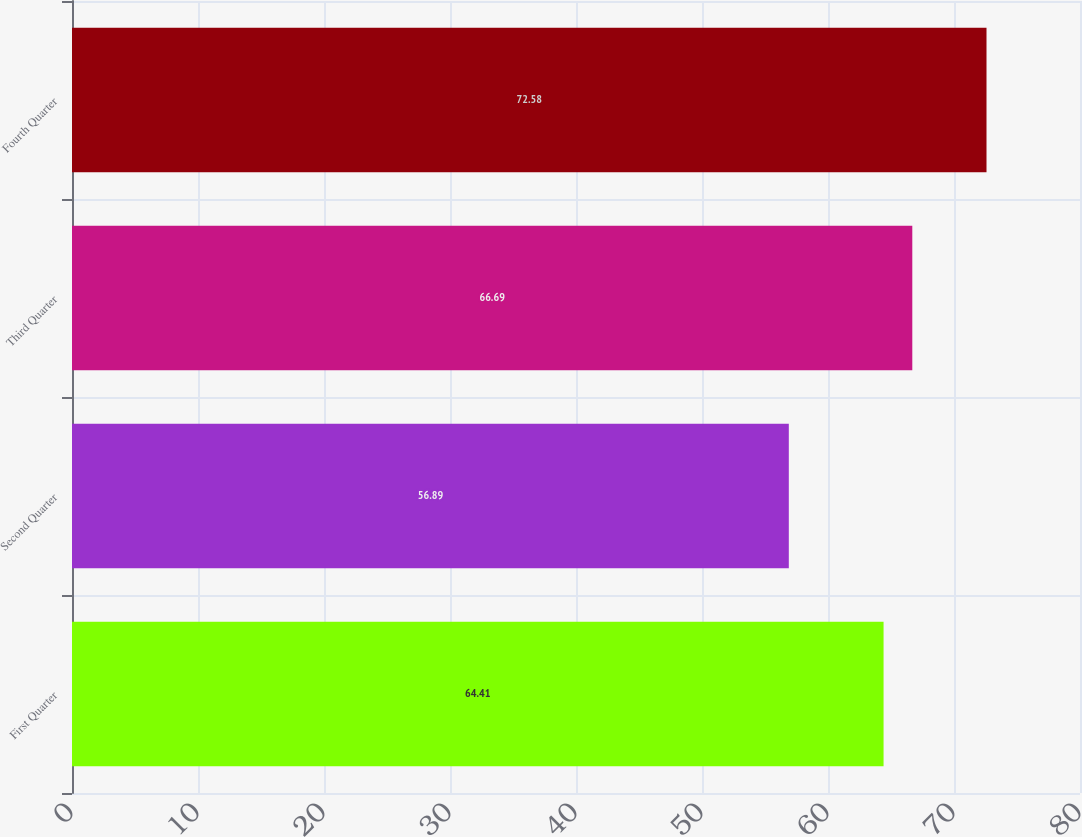Convert chart. <chart><loc_0><loc_0><loc_500><loc_500><bar_chart><fcel>First Quarter<fcel>Second Quarter<fcel>Third Quarter<fcel>Fourth Quarter<nl><fcel>64.41<fcel>56.89<fcel>66.69<fcel>72.58<nl></chart> 